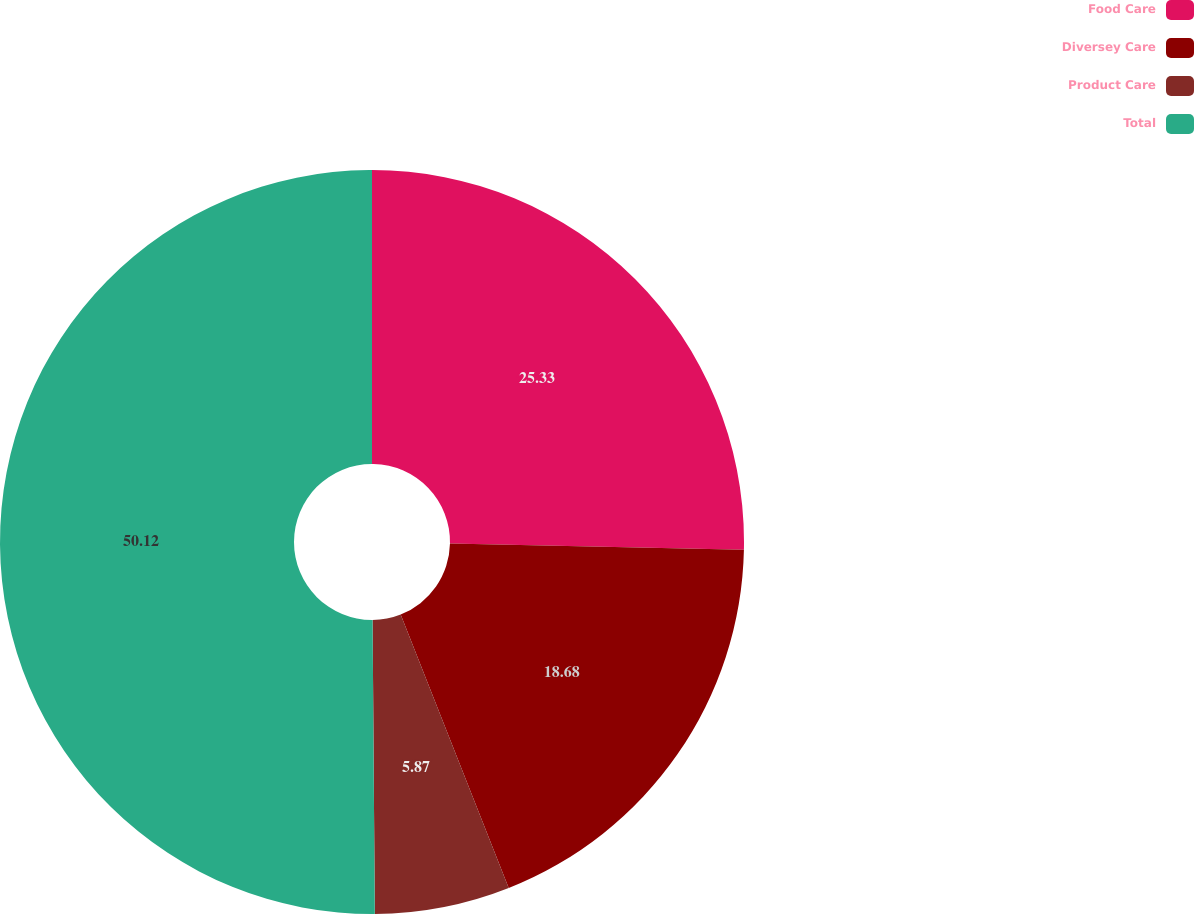<chart> <loc_0><loc_0><loc_500><loc_500><pie_chart><fcel>Food Care<fcel>Diversey Care<fcel>Product Care<fcel>Total<nl><fcel>25.33%<fcel>18.68%<fcel>5.87%<fcel>50.12%<nl></chart> 